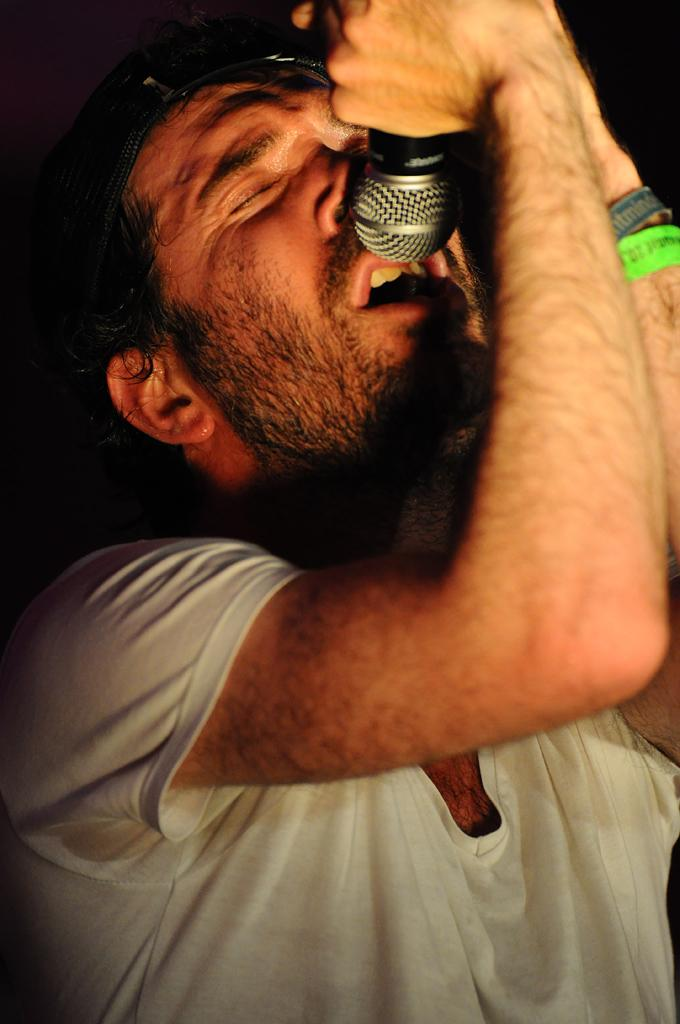What is the main subject of the image? There is a person in the image. What is the person holding in his hands? The person is holding a microphone in his hands. How does the person's son react to the test in the image? There is no son or test present in the image; it only features a person holding a microphone. 